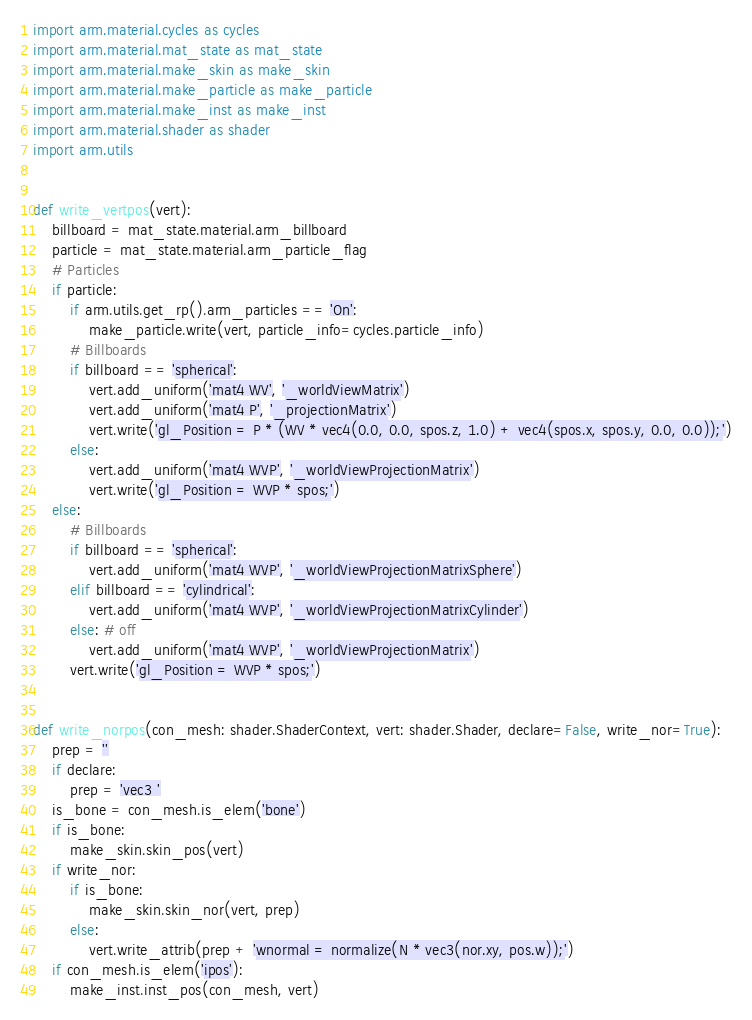<code> <loc_0><loc_0><loc_500><loc_500><_Python_>import arm.material.cycles as cycles
import arm.material.mat_state as mat_state
import arm.material.make_skin as make_skin
import arm.material.make_particle as make_particle
import arm.material.make_inst as make_inst
import arm.material.shader as shader
import arm.utils


def write_vertpos(vert):
    billboard = mat_state.material.arm_billboard
    particle = mat_state.material.arm_particle_flag
    # Particles
    if particle:
        if arm.utils.get_rp().arm_particles == 'On':
            make_particle.write(vert, particle_info=cycles.particle_info)
        # Billboards
        if billboard == 'spherical':
            vert.add_uniform('mat4 WV', '_worldViewMatrix')
            vert.add_uniform('mat4 P', '_projectionMatrix')
            vert.write('gl_Position = P * (WV * vec4(0.0, 0.0, spos.z, 1.0) + vec4(spos.x, spos.y, 0.0, 0.0));')
        else:
            vert.add_uniform('mat4 WVP', '_worldViewProjectionMatrix')
            vert.write('gl_Position = WVP * spos;')
    else:
        # Billboards
        if billboard == 'spherical':
            vert.add_uniform('mat4 WVP', '_worldViewProjectionMatrixSphere')
        elif billboard == 'cylindrical':
            vert.add_uniform('mat4 WVP', '_worldViewProjectionMatrixCylinder')
        else: # off
            vert.add_uniform('mat4 WVP', '_worldViewProjectionMatrix')
        vert.write('gl_Position = WVP * spos;')


def write_norpos(con_mesh: shader.ShaderContext, vert: shader.Shader, declare=False, write_nor=True):
    prep = ''
    if declare:
        prep = 'vec3 '
    is_bone = con_mesh.is_elem('bone')
    if is_bone:
        make_skin.skin_pos(vert)
    if write_nor:
        if is_bone:
            make_skin.skin_nor(vert, prep)
        else:
            vert.write_attrib(prep + 'wnormal = normalize(N * vec3(nor.xy, pos.w));')
    if con_mesh.is_elem('ipos'):
        make_inst.inst_pos(con_mesh, vert)
</code> 